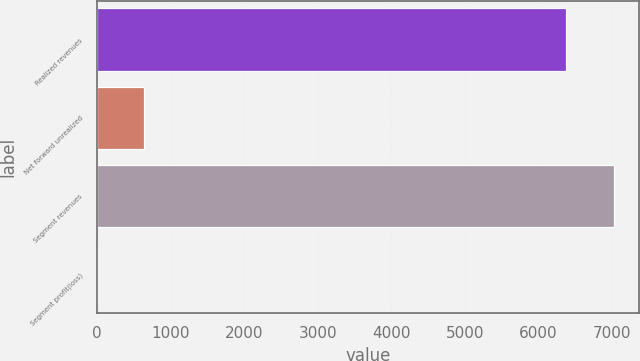Convert chart to OTSL. <chart><loc_0><loc_0><loc_500><loc_500><bar_chart><fcel>Realized revenues<fcel>Net forward unrealized<fcel>Segment revenues<fcel>Segment profit(loss)<nl><fcel>6385<fcel>643.9<fcel>7025.9<fcel>3<nl></chart> 